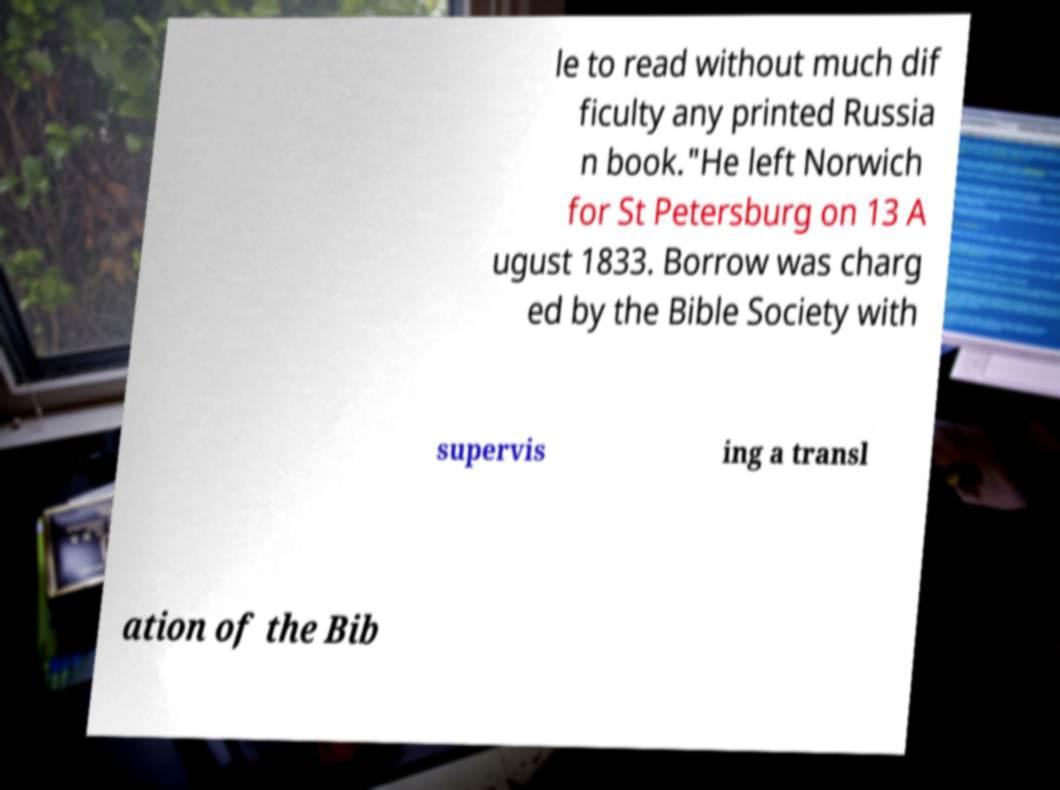There's text embedded in this image that I need extracted. Can you transcribe it verbatim? le to read without much dif ficulty any printed Russia n book."He left Norwich for St Petersburg on 13 A ugust 1833. Borrow was charg ed by the Bible Society with supervis ing a transl ation of the Bib 